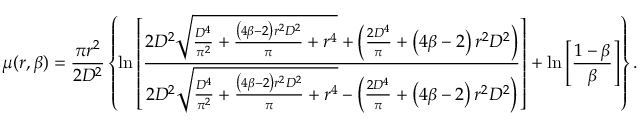<formula> <loc_0><loc_0><loc_500><loc_500>\mu ( r , \beta ) = \frac { \pi r ^ { 2 } } { 2 D ^ { 2 } } \left \{ \ln \left [ \frac { 2 D ^ { 2 } \sqrt { \frac { D ^ { 4 } } { \pi ^ { 2 } } + \frac { \left ( 4 \beta - 2 \right ) r ^ { 2 } D ^ { 2 } } { \pi } + r ^ { 4 } } + \left ( \frac { 2 D ^ { 4 } } { \pi } + \left ( 4 \beta - 2 \right ) r ^ { 2 } D ^ { 2 } \right ) } { 2 D ^ { 2 } \sqrt { \frac { D ^ { 4 } } { \pi ^ { 2 } } + \frac { \left ( 4 \beta - 2 \right ) r ^ { 2 } D ^ { 2 } } { \pi } + r ^ { 4 } } - \left ( \frac { 2 D ^ { 4 } } { \pi } + \left ( 4 \beta - 2 \right ) r ^ { 2 } D ^ { 2 } \right ) } \right ] + \ln \left [ \frac { 1 - \beta } { \beta } \right ] \right \} .</formula> 